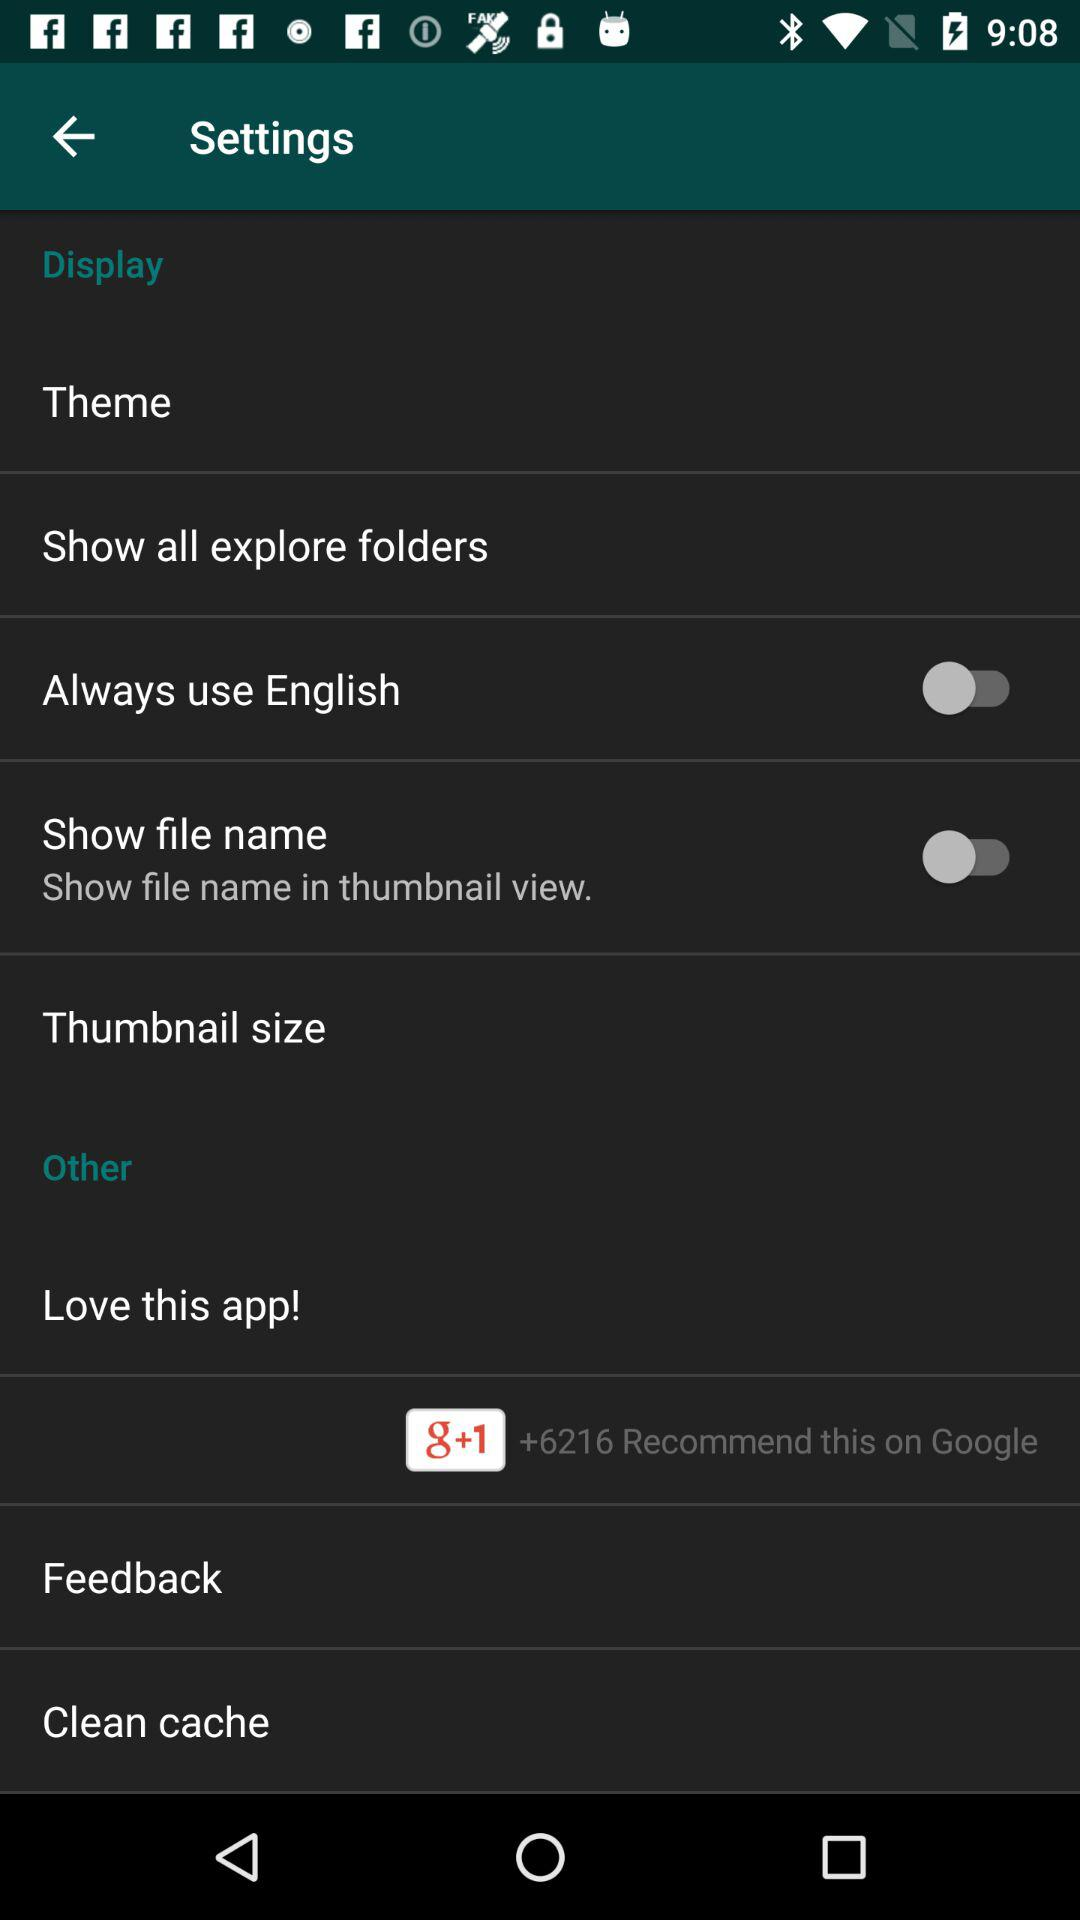What is the status of the "Always use English" setting? The status is "off". 